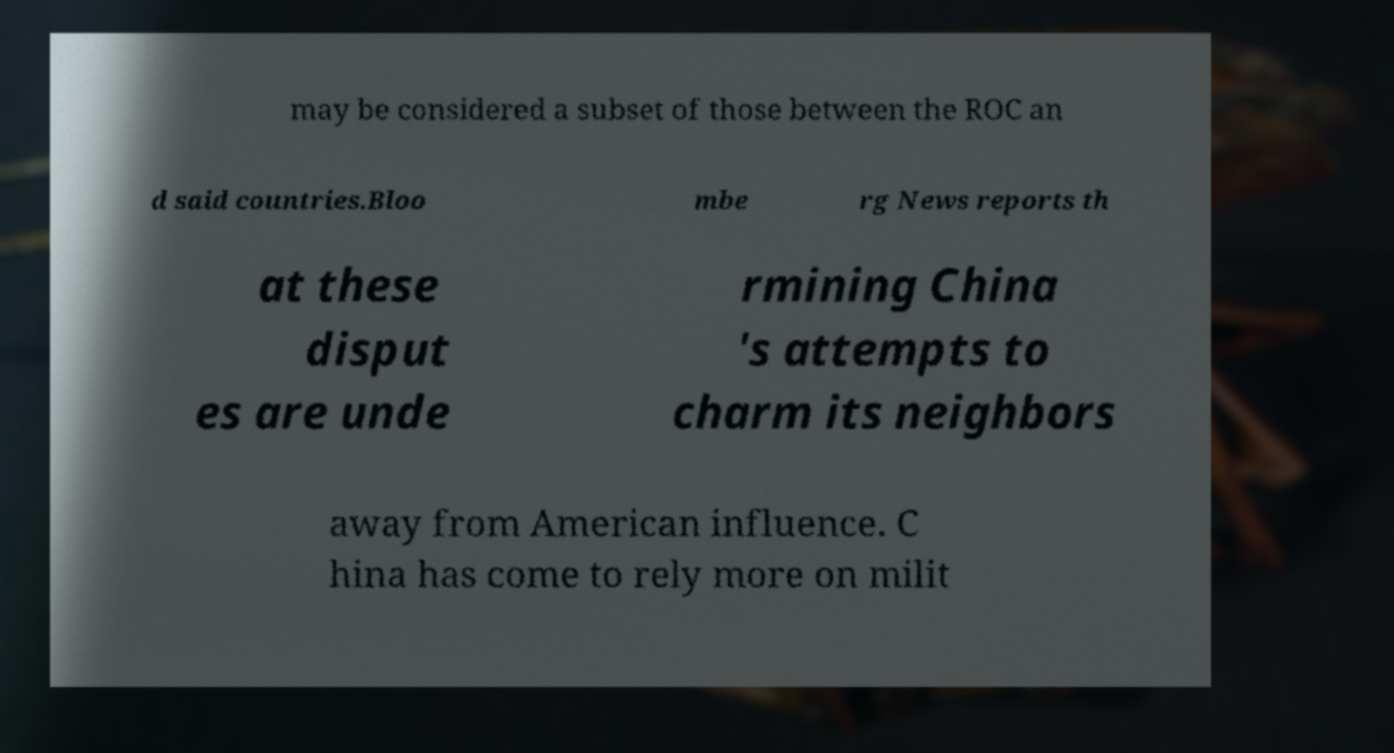I need the written content from this picture converted into text. Can you do that? may be considered a subset of those between the ROC an d said countries.Bloo mbe rg News reports th at these disput es are unde rmining China 's attempts to charm its neighbors away from American influence. C hina has come to rely more on milit 